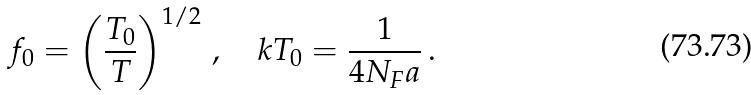Convert formula to latex. <formula><loc_0><loc_0><loc_500><loc_500>f _ { 0 } = \left ( \frac { T _ { 0 } } T \right ) ^ { 1 / 2 } \, , \quad k T _ { 0 } = { \frac { 1 } { 4 N _ { F } a } } \, .</formula> 